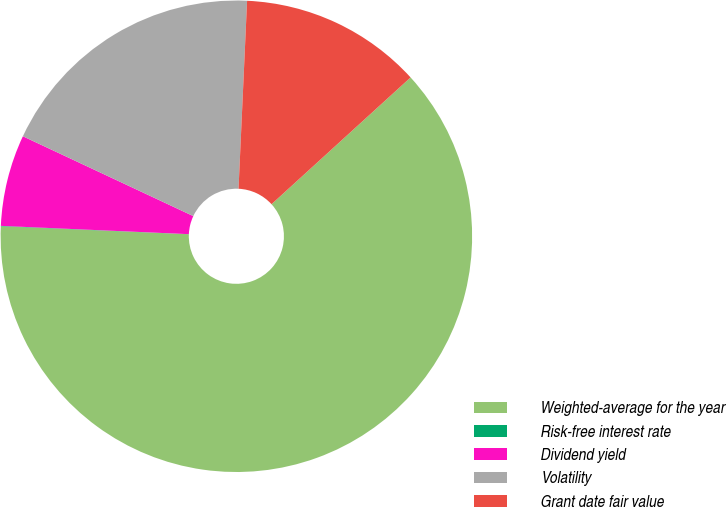Convert chart. <chart><loc_0><loc_0><loc_500><loc_500><pie_chart><fcel>Weighted-average for the year<fcel>Risk-free interest rate<fcel>Dividend yield<fcel>Volatility<fcel>Grant date fair value<nl><fcel>62.43%<fcel>0.03%<fcel>6.27%<fcel>18.75%<fcel>12.51%<nl></chart> 